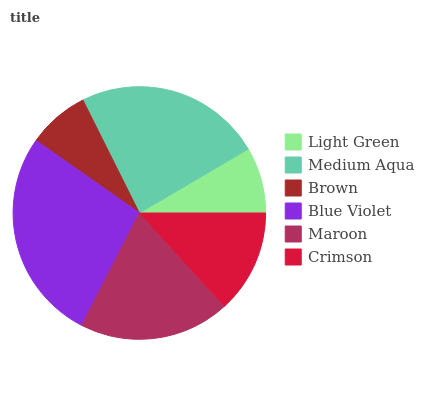Is Brown the minimum?
Answer yes or no. Yes. Is Blue Violet the maximum?
Answer yes or no. Yes. Is Medium Aqua the minimum?
Answer yes or no. No. Is Medium Aqua the maximum?
Answer yes or no. No. Is Medium Aqua greater than Light Green?
Answer yes or no. Yes. Is Light Green less than Medium Aqua?
Answer yes or no. Yes. Is Light Green greater than Medium Aqua?
Answer yes or no. No. Is Medium Aqua less than Light Green?
Answer yes or no. No. Is Maroon the high median?
Answer yes or no. Yes. Is Crimson the low median?
Answer yes or no. Yes. Is Brown the high median?
Answer yes or no. No. Is Brown the low median?
Answer yes or no. No. 